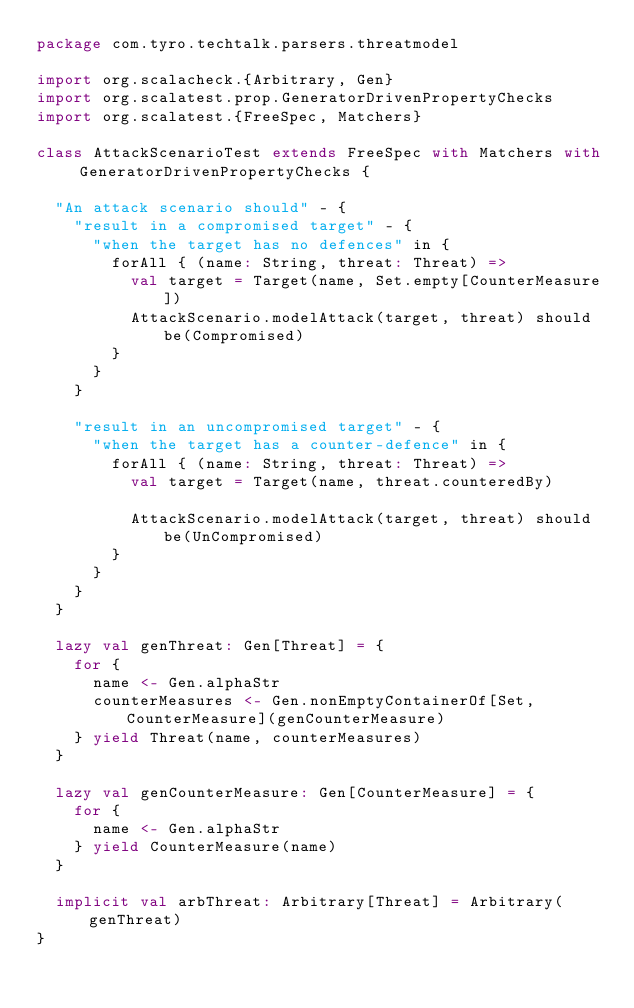Convert code to text. <code><loc_0><loc_0><loc_500><loc_500><_Scala_>package com.tyro.techtalk.parsers.threatmodel

import org.scalacheck.{Arbitrary, Gen}
import org.scalatest.prop.GeneratorDrivenPropertyChecks
import org.scalatest.{FreeSpec, Matchers}

class AttackScenarioTest extends FreeSpec with Matchers with GeneratorDrivenPropertyChecks {

  "An attack scenario should" - {
    "result in a compromised target" - {
      "when the target has no defences" in {
        forAll { (name: String, threat: Threat) =>
          val target = Target(name, Set.empty[CounterMeasure])
          AttackScenario.modelAttack(target, threat) should be(Compromised)
        }
      }
    }

    "result in an uncompromised target" - {
      "when the target has a counter-defence" in {
        forAll { (name: String, threat: Threat) =>
          val target = Target(name, threat.counteredBy)

          AttackScenario.modelAttack(target, threat) should be(UnCompromised)
        }
      }
    }
  }

  lazy val genThreat: Gen[Threat] = {
    for {
      name <- Gen.alphaStr
      counterMeasures <- Gen.nonEmptyContainerOf[Set, CounterMeasure](genCounterMeasure)
    } yield Threat(name, counterMeasures)
  }

  lazy val genCounterMeasure: Gen[CounterMeasure] = {
    for {
      name <- Gen.alphaStr
    } yield CounterMeasure(name)
  }

  implicit val arbThreat: Arbitrary[Threat] = Arbitrary(genThreat)
}
</code> 